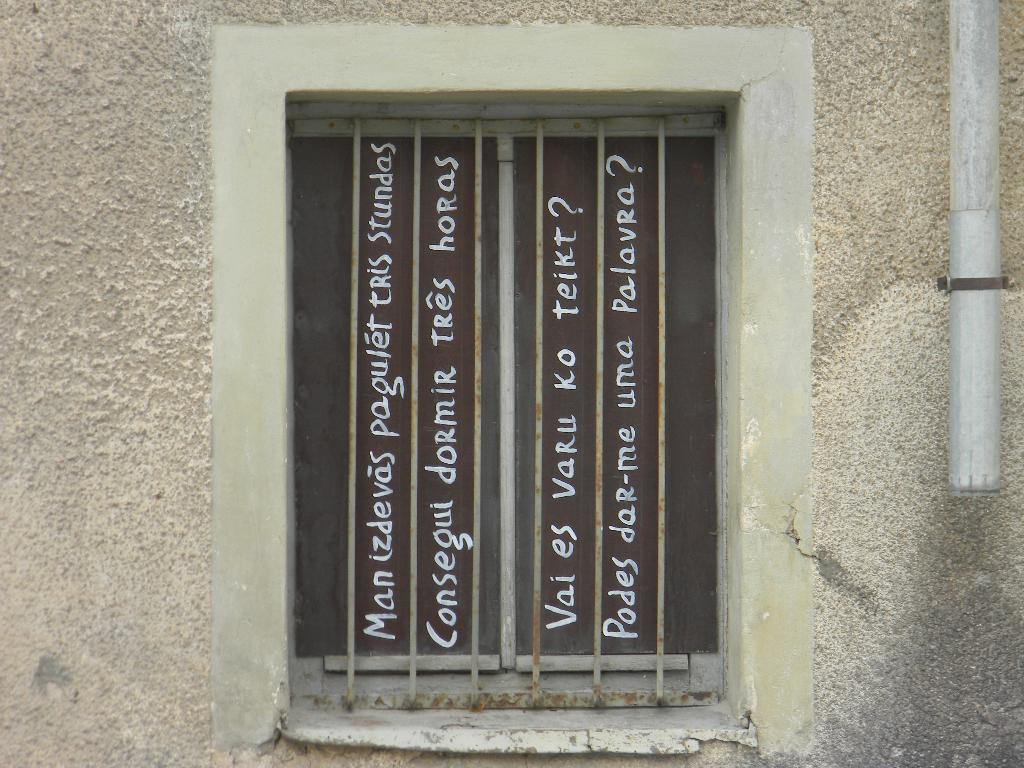What architectural feature is present in the middle of a wall in the image? There is a window in the image. Can you describe the location of the window in the image? The window is in the middle of a wall. What is visible on the window in the image? There is text visible on the window. How many chickens are visible on the window in the image? There are no chickens visible on the window in the image. What type of note is attached to the window in the image? There is no note attached to the window in the image; only text is visible. 